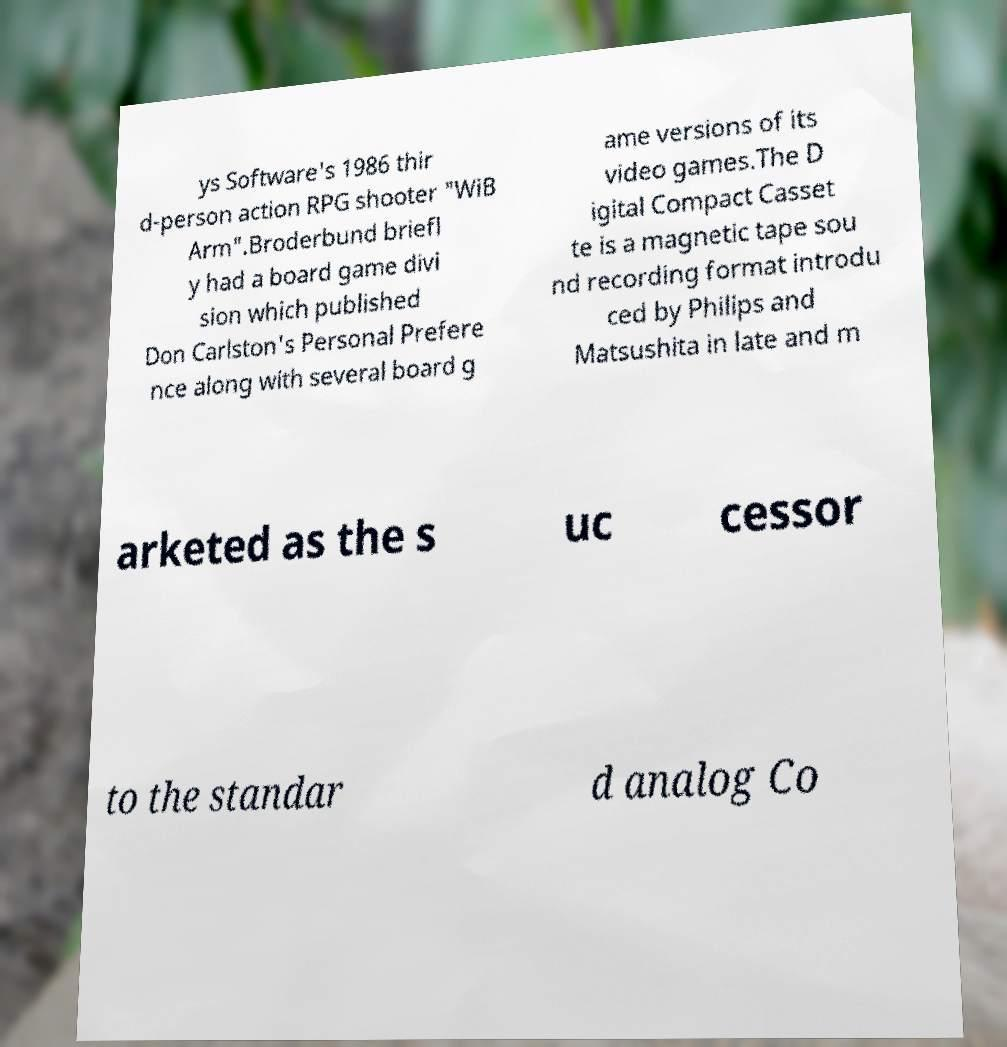Please read and relay the text visible in this image. What does it say? ys Software's 1986 thir d-person action RPG shooter "WiB Arm".Broderbund briefl y had a board game divi sion which published Don Carlston's Personal Prefere nce along with several board g ame versions of its video games.The D igital Compact Casset te is a magnetic tape sou nd recording format introdu ced by Philips and Matsushita in late and m arketed as the s uc cessor to the standar d analog Co 